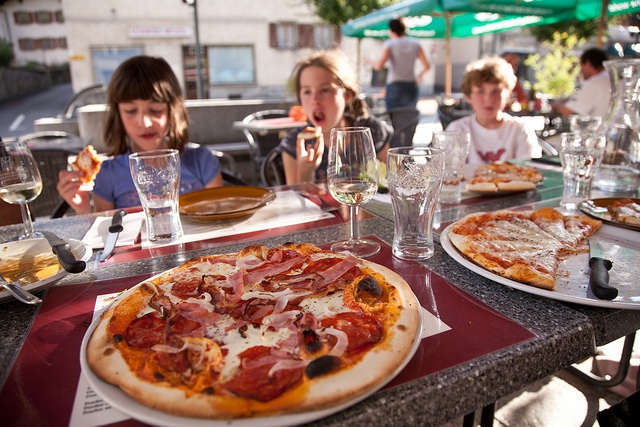Describe the objects in this image and their specific colors. I can see pizza in black, maroon, brown, and tan tones, dining table in black, maroon, and gray tones, people in black, brown, purple, and maroon tones, people in black, brown, ivory, maroon, and salmon tones, and pizza in black, tan, brown, salmon, and darkgray tones in this image. 